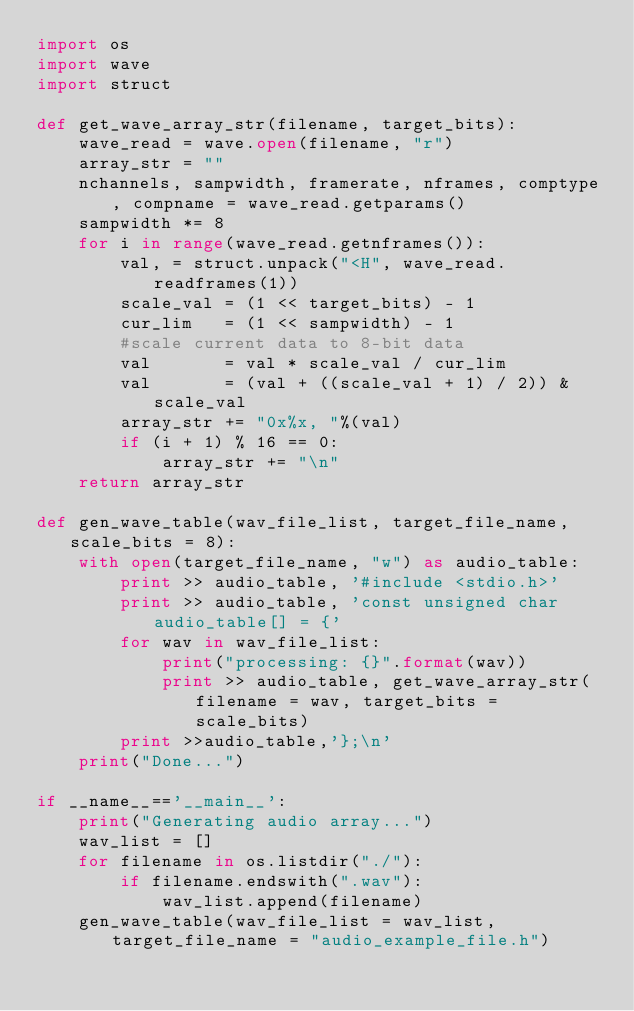Convert code to text. <code><loc_0><loc_0><loc_500><loc_500><_Python_>import os
import wave
import struct

def get_wave_array_str(filename, target_bits):
    wave_read = wave.open(filename, "r")
    array_str = ""
    nchannels, sampwidth, framerate, nframes, comptype, compname = wave_read.getparams()
    sampwidth *= 8
    for i in range(wave_read.getnframes()):
        val, = struct.unpack("<H", wave_read.readframes(1))
        scale_val = (1 << target_bits) - 1
        cur_lim   = (1 << sampwidth) - 1
        #scale current data to 8-bit data
        val       = val * scale_val / cur_lim
        val       = (val + ((scale_val + 1) / 2)) & scale_val
        array_str += "0x%x, "%(val)
        if (i + 1) % 16 == 0:
            array_str += "\n"
    return array_str

def gen_wave_table(wav_file_list, target_file_name, scale_bits = 8):
    with open(target_file_name, "w") as audio_table:
        print >> audio_table, '#include <stdio.h>'
        print >> audio_table, 'const unsigned char audio_table[] = {'
        for wav in wav_file_list:
            print("processing: {}".format(wav))
            print >> audio_table, get_wave_array_str(filename = wav, target_bits = scale_bits)
        print >>audio_table,'};\n'
    print("Done...")

if __name__=='__main__':
    print("Generating audio array...")
    wav_list = []
    for filename in os.listdir("./"):
        if filename.endswith(".wav"):
            wav_list.append(filename)
    gen_wave_table(wav_file_list = wav_list, target_file_name = "audio_example_file.h")
</code> 